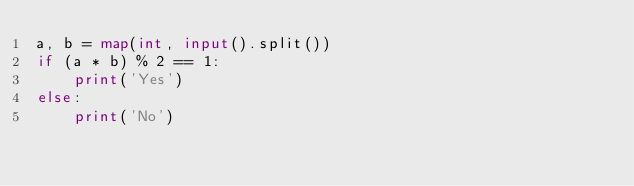<code> <loc_0><loc_0><loc_500><loc_500><_Python_>a, b = map(int, input().split())
if (a * b) % 2 == 1:
    print('Yes')
else:
    print('No') </code> 